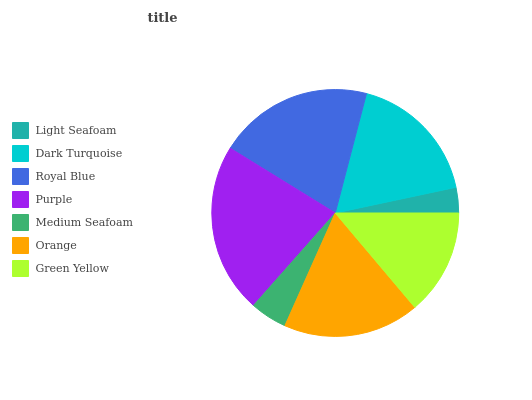Is Light Seafoam the minimum?
Answer yes or no. Yes. Is Purple the maximum?
Answer yes or no. Yes. Is Dark Turquoise the minimum?
Answer yes or no. No. Is Dark Turquoise the maximum?
Answer yes or no. No. Is Dark Turquoise greater than Light Seafoam?
Answer yes or no. Yes. Is Light Seafoam less than Dark Turquoise?
Answer yes or no. Yes. Is Light Seafoam greater than Dark Turquoise?
Answer yes or no. No. Is Dark Turquoise less than Light Seafoam?
Answer yes or no. No. Is Dark Turquoise the high median?
Answer yes or no. Yes. Is Dark Turquoise the low median?
Answer yes or no. Yes. Is Green Yellow the high median?
Answer yes or no. No. Is Medium Seafoam the low median?
Answer yes or no. No. 